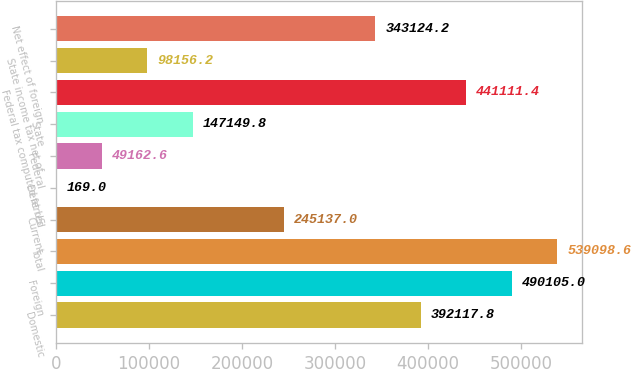<chart> <loc_0><loc_0><loc_500><loc_500><bar_chart><fcel>Domestic<fcel>Foreign<fcel>Total<fcel>Current<fcel>Deferred<fcel>Federal<fcel>State<fcel>Federal tax computed at US<fcel>State income tax net of<fcel>Net effect of foreign<nl><fcel>392118<fcel>490105<fcel>539099<fcel>245137<fcel>169<fcel>49162.6<fcel>147150<fcel>441111<fcel>98156.2<fcel>343124<nl></chart> 